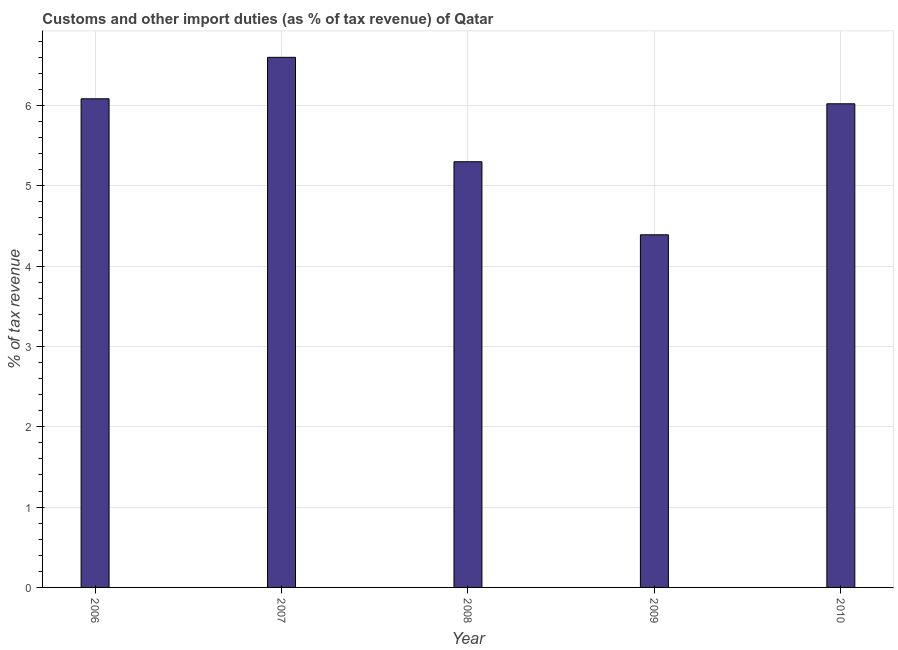Does the graph contain any zero values?
Provide a short and direct response. No. What is the title of the graph?
Keep it short and to the point. Customs and other import duties (as % of tax revenue) of Qatar. What is the label or title of the X-axis?
Offer a very short reply. Year. What is the label or title of the Y-axis?
Offer a terse response. % of tax revenue. What is the customs and other import duties in 2008?
Offer a terse response. 5.3. Across all years, what is the maximum customs and other import duties?
Your answer should be compact. 6.6. Across all years, what is the minimum customs and other import duties?
Ensure brevity in your answer.  4.39. In which year was the customs and other import duties minimum?
Ensure brevity in your answer.  2009. What is the sum of the customs and other import duties?
Keep it short and to the point. 28.39. What is the average customs and other import duties per year?
Provide a short and direct response. 5.68. What is the median customs and other import duties?
Provide a succinct answer. 6.02. In how many years, is the customs and other import duties greater than 0.2 %?
Your response must be concise. 5. What is the ratio of the customs and other import duties in 2006 to that in 2007?
Offer a very short reply. 0.92. What is the difference between the highest and the second highest customs and other import duties?
Give a very brief answer. 0.52. Is the sum of the customs and other import duties in 2009 and 2010 greater than the maximum customs and other import duties across all years?
Give a very brief answer. Yes. What is the difference between the highest and the lowest customs and other import duties?
Give a very brief answer. 2.21. In how many years, is the customs and other import duties greater than the average customs and other import duties taken over all years?
Ensure brevity in your answer.  3. Are all the bars in the graph horizontal?
Make the answer very short. No. What is the % of tax revenue in 2006?
Your response must be concise. 6.08. What is the % of tax revenue of 2007?
Your answer should be compact. 6.6. What is the % of tax revenue of 2008?
Provide a succinct answer. 5.3. What is the % of tax revenue in 2009?
Provide a succinct answer. 4.39. What is the % of tax revenue of 2010?
Make the answer very short. 6.02. What is the difference between the % of tax revenue in 2006 and 2007?
Your response must be concise. -0.52. What is the difference between the % of tax revenue in 2006 and 2008?
Make the answer very short. 0.78. What is the difference between the % of tax revenue in 2006 and 2009?
Keep it short and to the point. 1.69. What is the difference between the % of tax revenue in 2006 and 2010?
Your answer should be very brief. 0.06. What is the difference between the % of tax revenue in 2007 and 2008?
Your answer should be compact. 1.3. What is the difference between the % of tax revenue in 2007 and 2009?
Your answer should be compact. 2.21. What is the difference between the % of tax revenue in 2007 and 2010?
Make the answer very short. 0.58. What is the difference between the % of tax revenue in 2008 and 2009?
Keep it short and to the point. 0.91. What is the difference between the % of tax revenue in 2008 and 2010?
Provide a short and direct response. -0.72. What is the difference between the % of tax revenue in 2009 and 2010?
Ensure brevity in your answer.  -1.63. What is the ratio of the % of tax revenue in 2006 to that in 2007?
Provide a succinct answer. 0.92. What is the ratio of the % of tax revenue in 2006 to that in 2008?
Provide a succinct answer. 1.15. What is the ratio of the % of tax revenue in 2006 to that in 2009?
Give a very brief answer. 1.39. What is the ratio of the % of tax revenue in 2007 to that in 2008?
Provide a short and direct response. 1.25. What is the ratio of the % of tax revenue in 2007 to that in 2009?
Make the answer very short. 1.5. What is the ratio of the % of tax revenue in 2007 to that in 2010?
Give a very brief answer. 1.1. What is the ratio of the % of tax revenue in 2008 to that in 2009?
Your response must be concise. 1.21. What is the ratio of the % of tax revenue in 2009 to that in 2010?
Your answer should be compact. 0.73. 